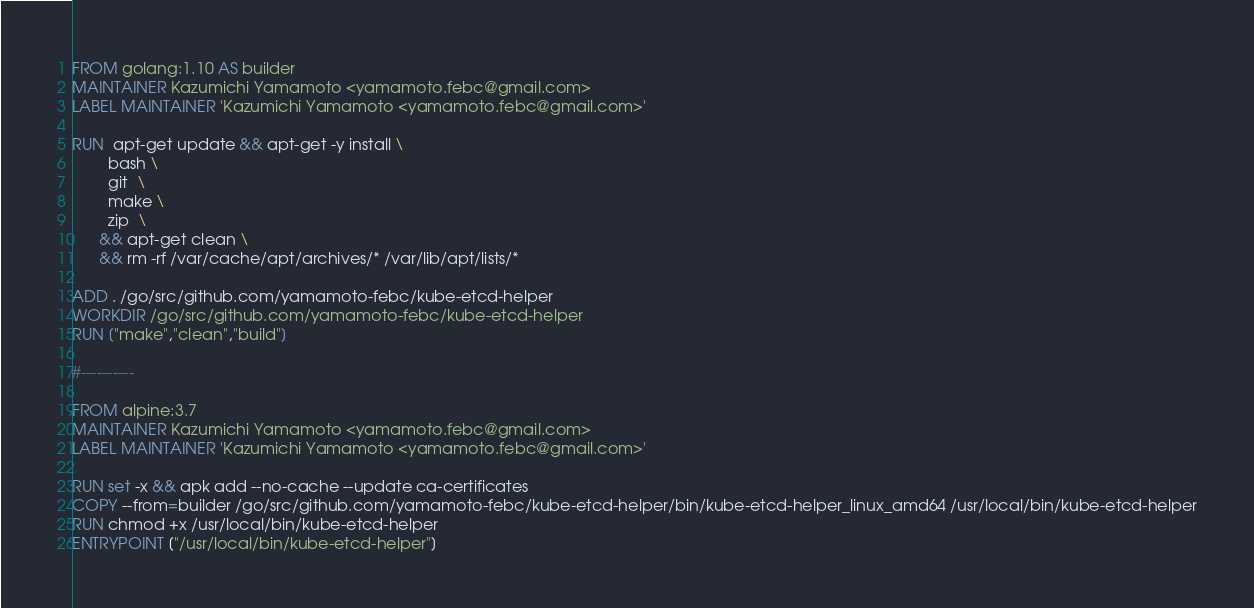<code> <loc_0><loc_0><loc_500><loc_500><_Dockerfile_>FROM golang:1.10 AS builder
MAINTAINER Kazumichi Yamamoto <yamamoto.febc@gmail.com>
LABEL MAINTAINER 'Kazumichi Yamamoto <yamamoto.febc@gmail.com>'

RUN  apt-get update && apt-get -y install \
        bash \
        git  \
        make \
        zip  \
      && apt-get clean \
      && rm -rf /var/cache/apt/archives/* /var/lib/apt/lists/*

ADD . /go/src/github.com/yamamoto-febc/kube-etcd-helper
WORKDIR /go/src/github.com/yamamoto-febc/kube-etcd-helper
RUN ["make","clean","build"]

#----------

FROM alpine:3.7
MAINTAINER Kazumichi Yamamoto <yamamoto.febc@gmail.com>
LABEL MAINTAINER 'Kazumichi Yamamoto <yamamoto.febc@gmail.com>'

RUN set -x && apk add --no-cache --update ca-certificates
COPY --from=builder /go/src/github.com/yamamoto-febc/kube-etcd-helper/bin/kube-etcd-helper_linux_amd64 /usr/local/bin/kube-etcd-helper
RUN chmod +x /usr/local/bin/kube-etcd-helper
ENTRYPOINT ["/usr/local/bin/kube-etcd-helper"]
</code> 